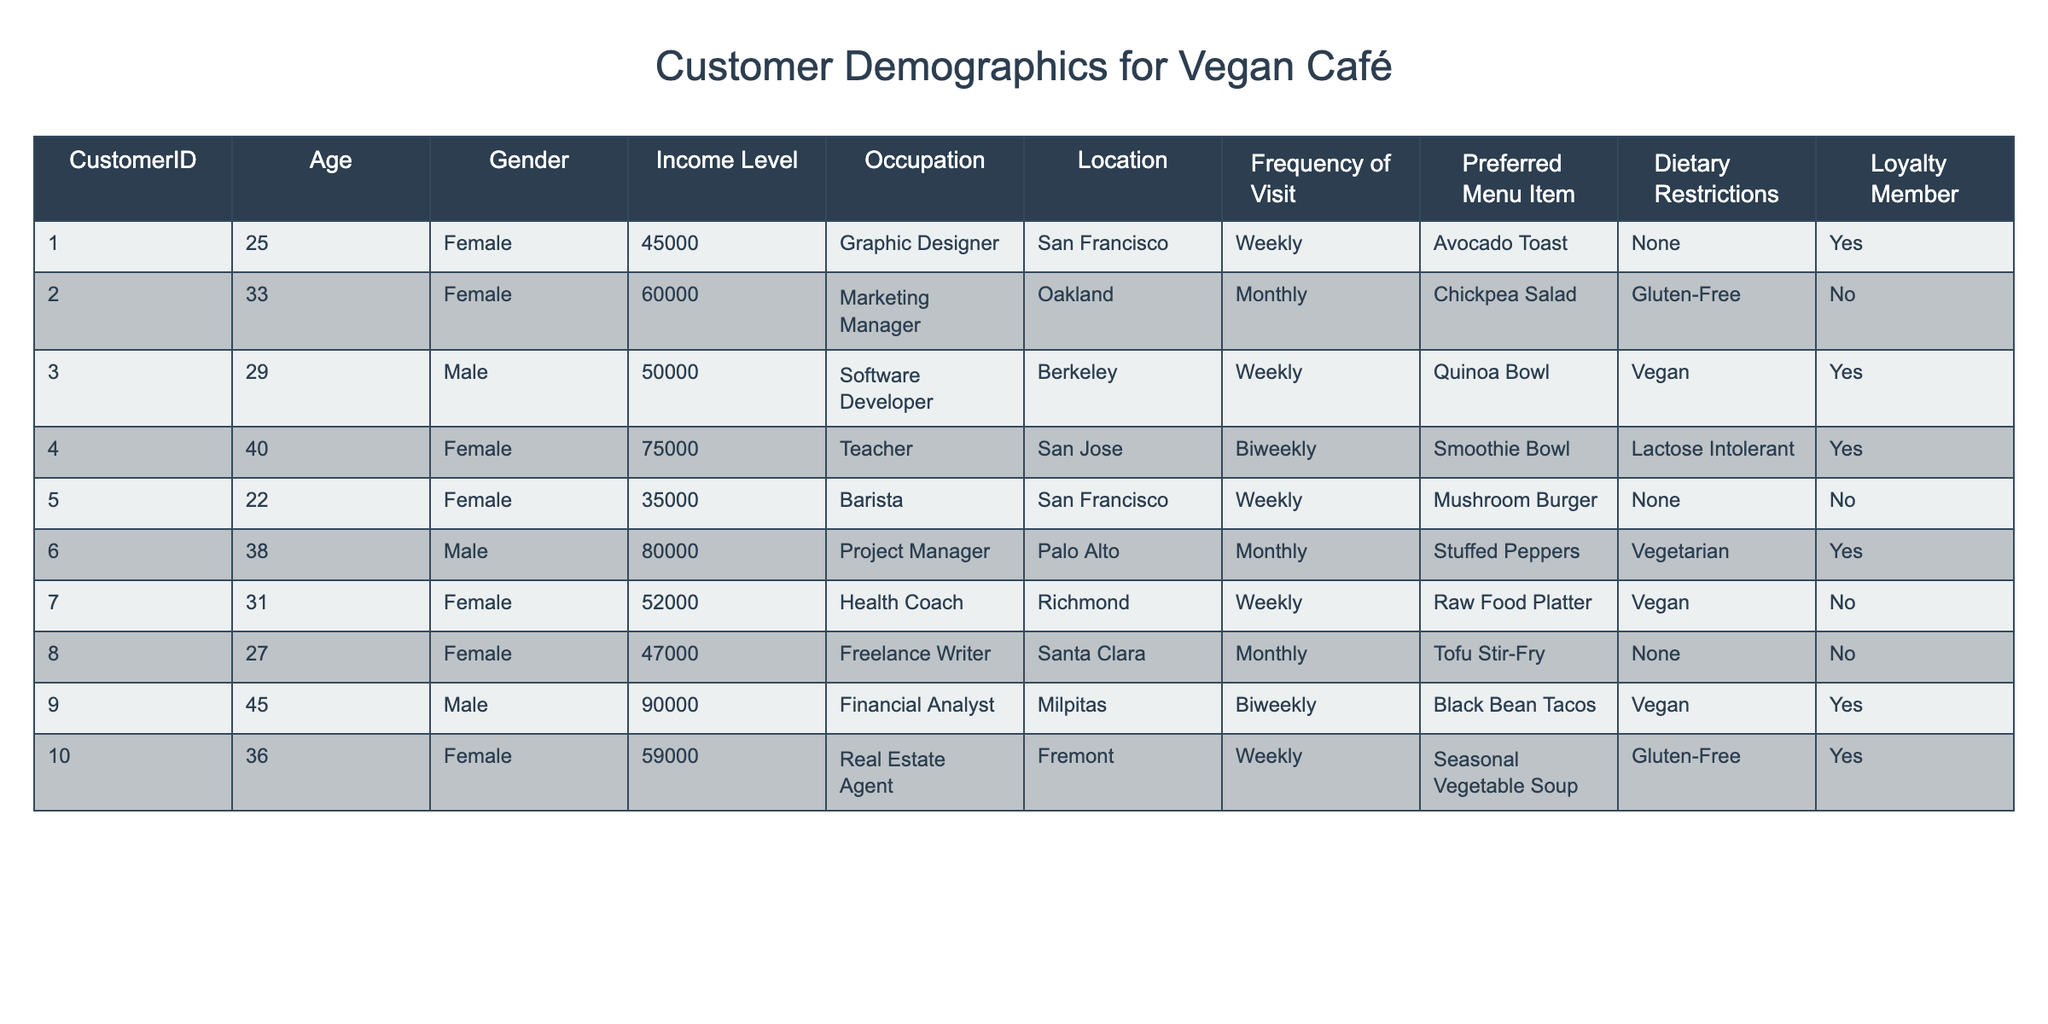What is the income level of the customer who visits biweekly? Looking at the table, the customers who visit biweekly are Customer IDs 4 and 9. For Customer ID 4, the income level is 75000, and for Customer ID 9, it is 90000. Therefore, the income level of customers who visit biweekly can be both 75000 and 90000.
Answer: 75000 and 90000 How many customers are loyalty members? In the table, I count the number of customers marked as loyalty members under the "Loyalty Member" column. Customers 1, 3, 4, 9, and 10 are marked as 'Yes,' totaling 5 loyalty members.
Answer: 5 What is the average age of customers who prefer "Vegan" menu items? I will first identify the customers preferring "Vegan" items, which are Customers 3, 7, and 9. Their ages are 29, 31, and 45 respectively. Summing these ages gives 29 + 31 + 45 = 105, and there are 3 customers, thus the average age is 105 / 3 = 35.
Answer: 35 Are there any customers who are both gluten-free and loyalty members? Looking at the relevant columns in the table, I see that Customer IDs 2 and 10 have gluten-free preferences. Checking the "Loyalty Member" status, Customer ID 10 is a loyalty member, so the answer is Yes.
Answer: Yes What is the difference in income between the highest and lowest income levels of customers who visit weekly? Customers who visit weekly are IDs 1, 3, 5, 7, and 10, with income levels of 45000, 50000, 35000, 52000, and 59000 respectively. The highest income is 59000 (Customer 10) and the lowest is 35000 (Customer 5). The difference in income is 59000 - 35000 = 24000.
Answer: 24000 How many customers are located in San Francisco? By checking the "Location" column, I find Customers 1 and 5 are located in San Francisco. Therefore, there are 2 customers in that location.
Answer: 2 Is there a customer who is a Graphic Designer and a loyalty member? From the table, Customer 1 is identified as a Graphic Designer and is also marked as a loyalty member (Yes). Thus, there is indeed such a customer.
Answer: Yes What percentage of customers have a dietary restriction of "None"? In total, there are 10 customers. Looking through the table, Customers 1, 5, and 8 have a dietary restriction of None, which is 3 customers. The percentage is calculated as (3/10) * 100 = 30%.
Answer: 30% Which customer has the highest income and what is their occupation? Scanning the income levels, Customer 9 has the highest income of 90000. Their occupation is "Financial Analyst."
Answer: 90000, Financial Analyst 